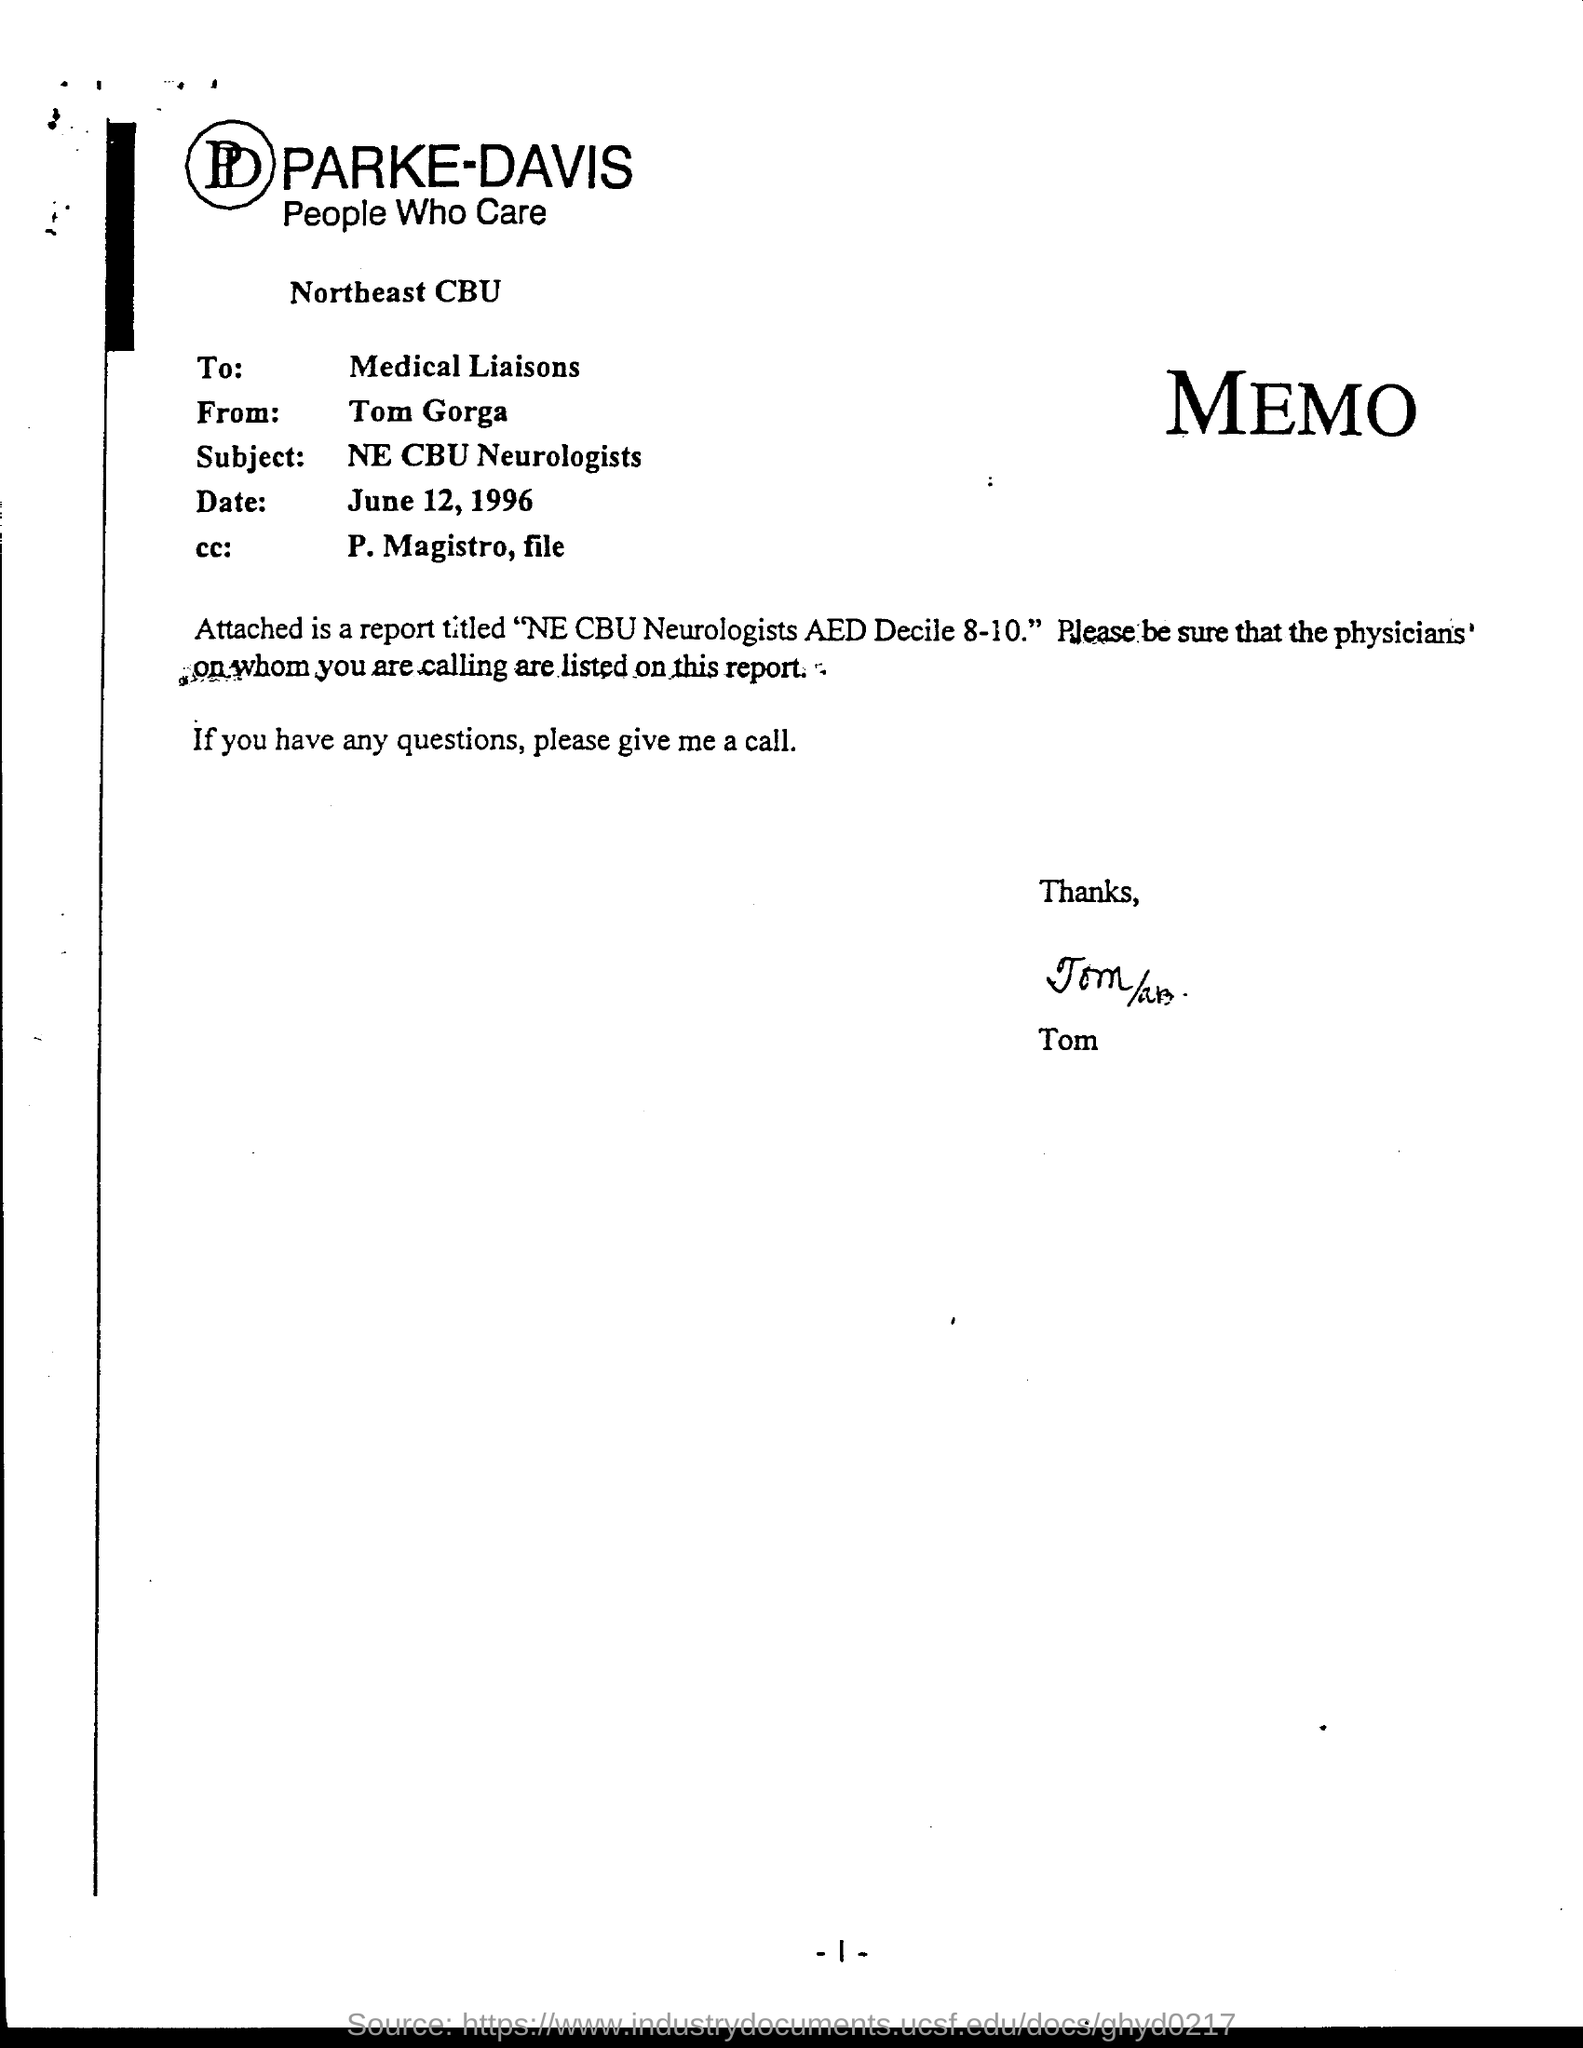To Whom is this memo addressed to?
Offer a very short reply. Medical Liaisons. Who is this memo from?
Offer a very short reply. Tom Gorga. What is the subject?
Your answer should be very brief. NE CBU Neurologists. What is the Date?
Ensure brevity in your answer.  June 12, 1996. Who is the cc: to?
Provide a short and direct response. P. Magistro, file. What is the Page Number?
Make the answer very short. -1-. 